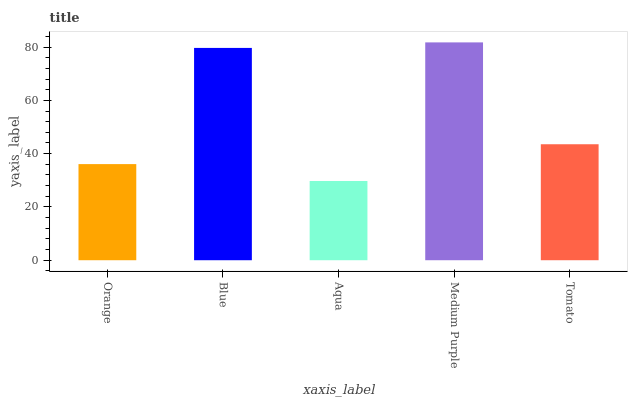Is Aqua the minimum?
Answer yes or no. Yes. Is Medium Purple the maximum?
Answer yes or no. Yes. Is Blue the minimum?
Answer yes or no. No. Is Blue the maximum?
Answer yes or no. No. Is Blue greater than Orange?
Answer yes or no. Yes. Is Orange less than Blue?
Answer yes or no. Yes. Is Orange greater than Blue?
Answer yes or no. No. Is Blue less than Orange?
Answer yes or no. No. Is Tomato the high median?
Answer yes or no. Yes. Is Tomato the low median?
Answer yes or no. Yes. Is Medium Purple the high median?
Answer yes or no. No. Is Orange the low median?
Answer yes or no. No. 